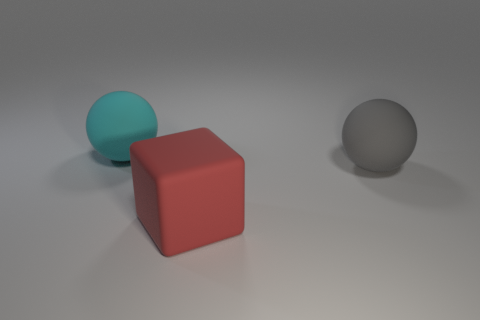Add 2 big red things. How many objects exist? 5 Subtract all blocks. How many objects are left? 2 Add 3 red blocks. How many red blocks are left? 4 Add 1 cyan matte cylinders. How many cyan matte cylinders exist? 1 Subtract 1 gray balls. How many objects are left? 2 Subtract all purple cubes. Subtract all spheres. How many objects are left? 1 